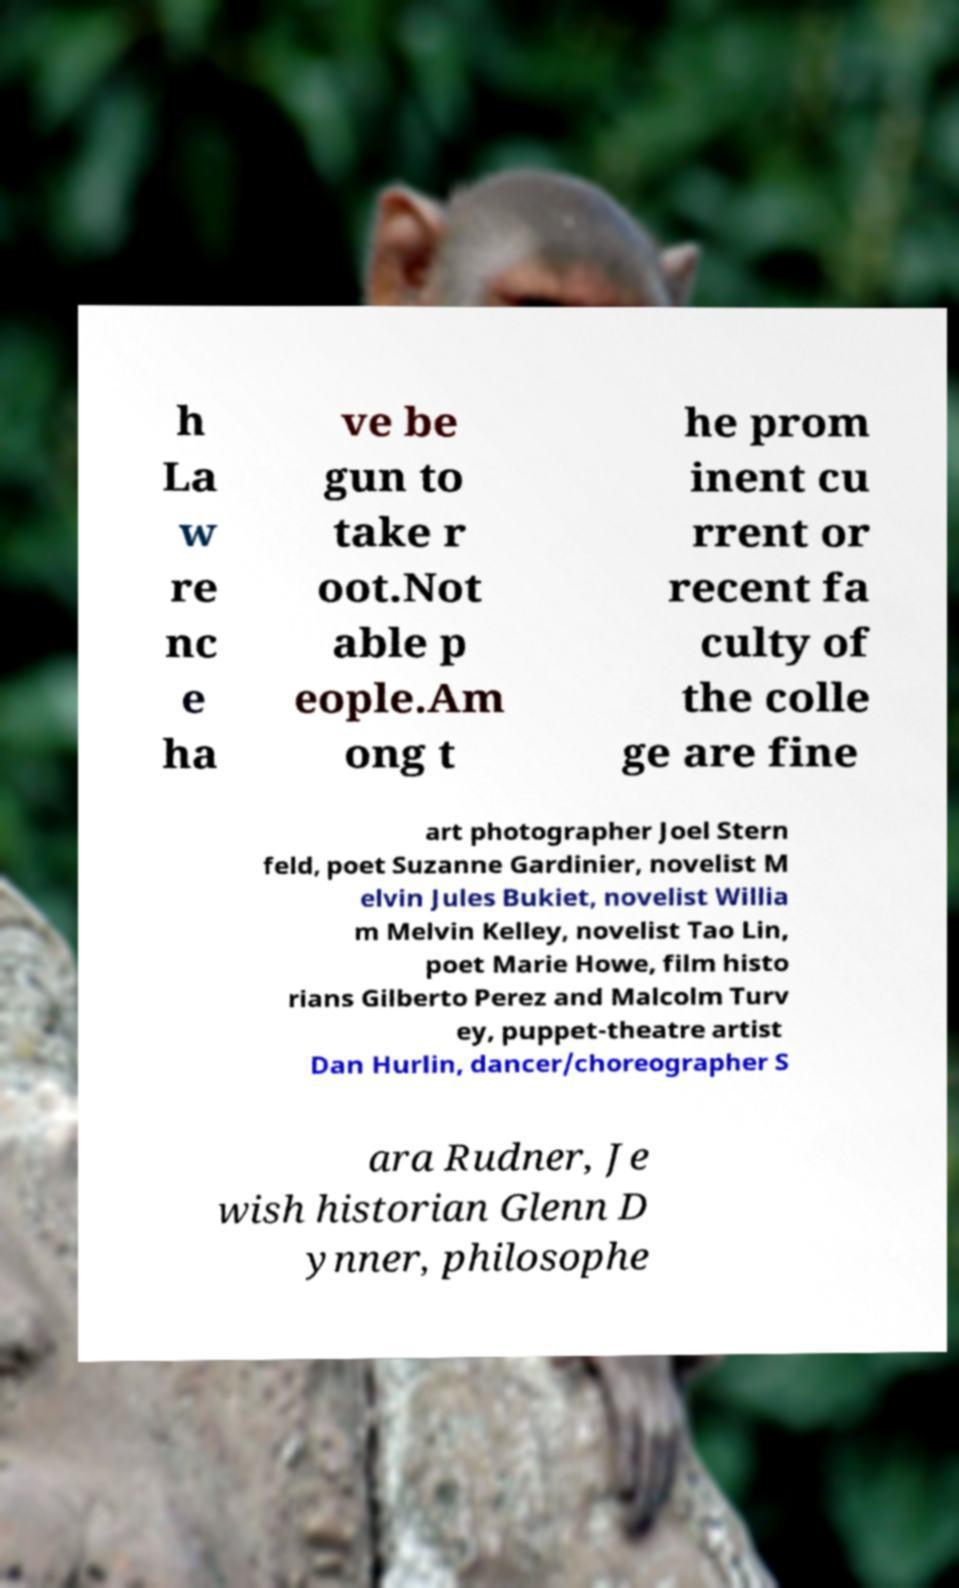What messages or text are displayed in this image? I need them in a readable, typed format. h La w re nc e ha ve be gun to take r oot.Not able p eople.Am ong t he prom inent cu rrent or recent fa culty of the colle ge are fine art photographer Joel Stern feld, poet Suzanne Gardinier, novelist M elvin Jules Bukiet, novelist Willia m Melvin Kelley, novelist Tao Lin, poet Marie Howe, film histo rians Gilberto Perez and Malcolm Turv ey, puppet-theatre artist Dan Hurlin, dancer/choreographer S ara Rudner, Je wish historian Glenn D ynner, philosophe 